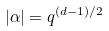<formula> <loc_0><loc_0><loc_500><loc_500>| \alpha | = q ^ { ( d - 1 ) / 2 }</formula> 